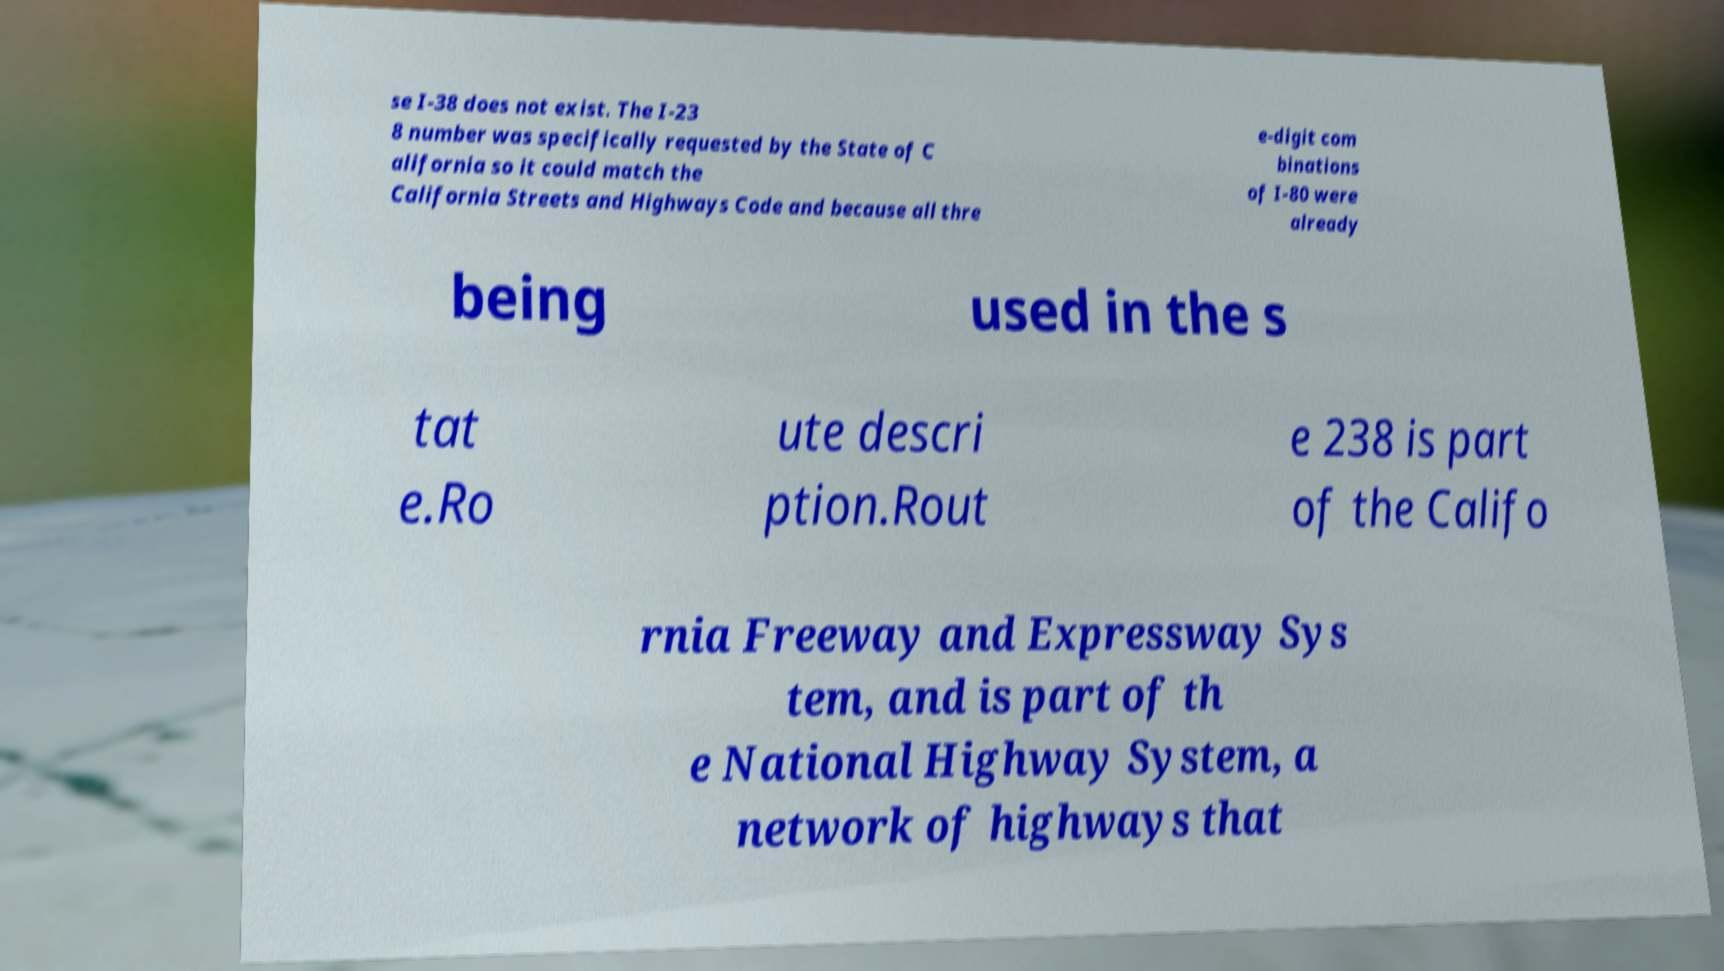For documentation purposes, I need the text within this image transcribed. Could you provide that? se I-38 does not exist. The I-23 8 number was specifically requested by the State of C alifornia so it could match the California Streets and Highways Code and because all thre e-digit com binations of I-80 were already being used in the s tat e.Ro ute descri ption.Rout e 238 is part of the Califo rnia Freeway and Expressway Sys tem, and is part of th e National Highway System, a network of highways that 